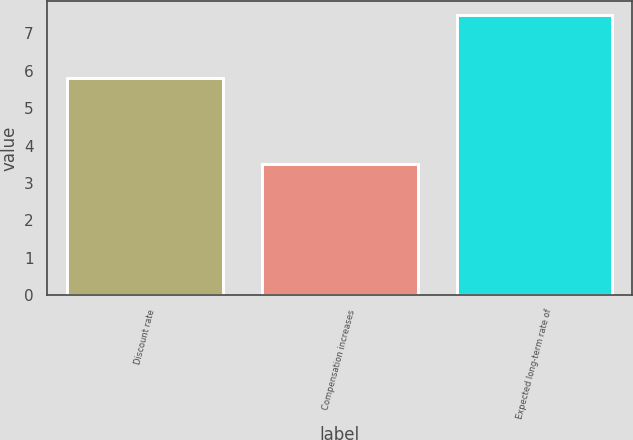Convert chart to OTSL. <chart><loc_0><loc_0><loc_500><loc_500><bar_chart><fcel>Discount rate<fcel>Compensation increases<fcel>Expected long-term rate of<nl><fcel>5.8<fcel>3.5<fcel>7.5<nl></chart> 